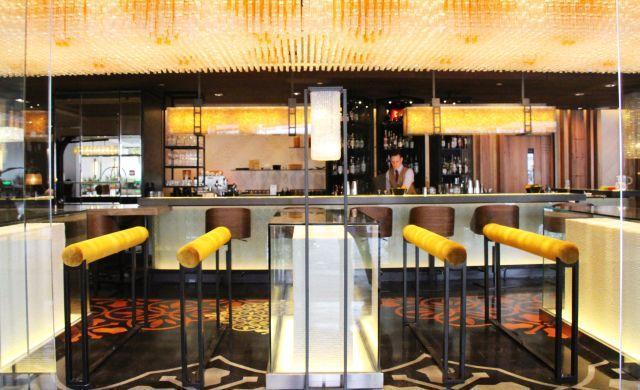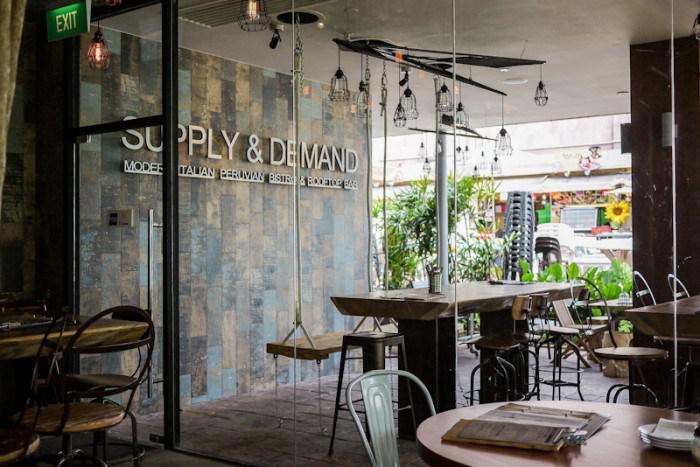The first image is the image on the left, the second image is the image on the right. Examine the images to the left and right. Is the description "In one image, green things are suspended from the ceiling over a dining area that includes square tables for four." accurate? Answer yes or no. No. The first image is the image on the left, the second image is the image on the right. Analyze the images presented: Is the assertion "Some tables have glass candle holders on them." valid? Answer yes or no. No. 